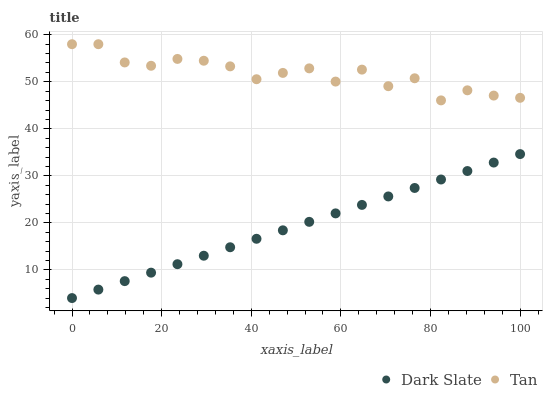Does Dark Slate have the minimum area under the curve?
Answer yes or no. Yes. Does Tan have the maximum area under the curve?
Answer yes or no. Yes. Does Tan have the minimum area under the curve?
Answer yes or no. No. Is Dark Slate the smoothest?
Answer yes or no. Yes. Is Tan the roughest?
Answer yes or no. Yes. Is Tan the smoothest?
Answer yes or no. No. Does Dark Slate have the lowest value?
Answer yes or no. Yes. Does Tan have the lowest value?
Answer yes or no. No. Does Tan have the highest value?
Answer yes or no. Yes. Is Dark Slate less than Tan?
Answer yes or no. Yes. Is Tan greater than Dark Slate?
Answer yes or no. Yes. Does Dark Slate intersect Tan?
Answer yes or no. No. 